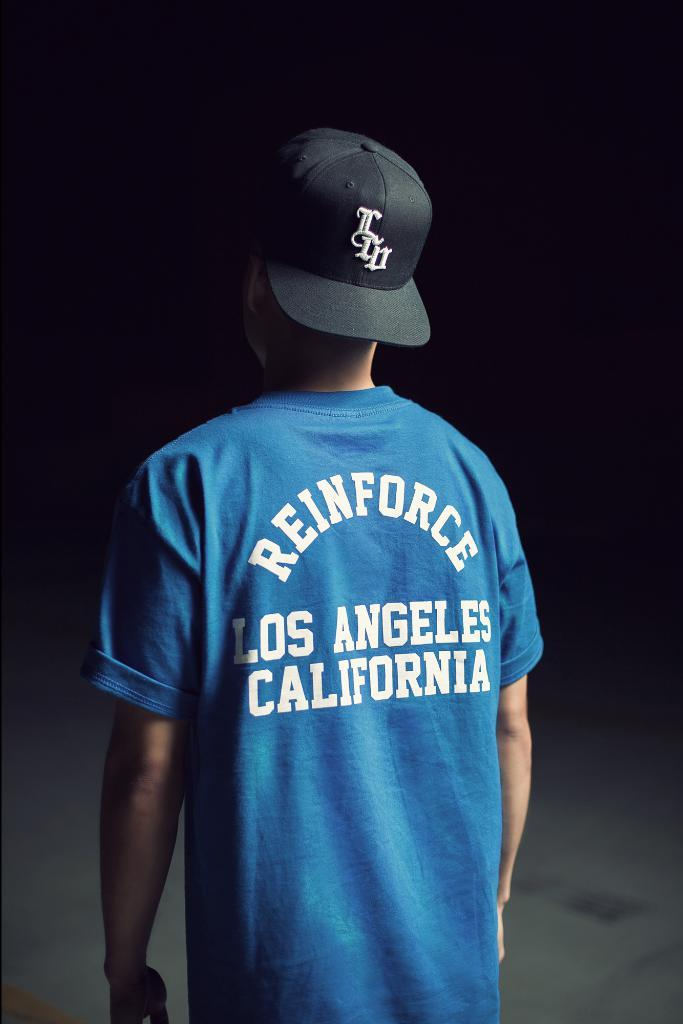Provide a one-sentence caption for the provided image. A blue tshirt with Reinforce Los Angeles California on it. 